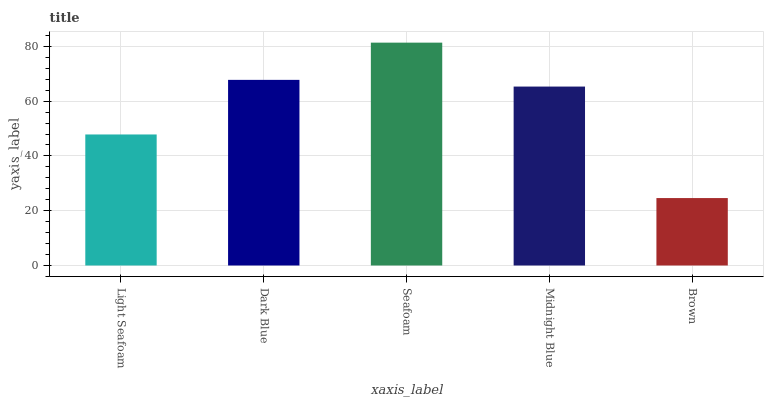Is Brown the minimum?
Answer yes or no. Yes. Is Seafoam the maximum?
Answer yes or no. Yes. Is Dark Blue the minimum?
Answer yes or no. No. Is Dark Blue the maximum?
Answer yes or no. No. Is Dark Blue greater than Light Seafoam?
Answer yes or no. Yes. Is Light Seafoam less than Dark Blue?
Answer yes or no. Yes. Is Light Seafoam greater than Dark Blue?
Answer yes or no. No. Is Dark Blue less than Light Seafoam?
Answer yes or no. No. Is Midnight Blue the high median?
Answer yes or no. Yes. Is Midnight Blue the low median?
Answer yes or no. Yes. Is Seafoam the high median?
Answer yes or no. No. Is Light Seafoam the low median?
Answer yes or no. No. 